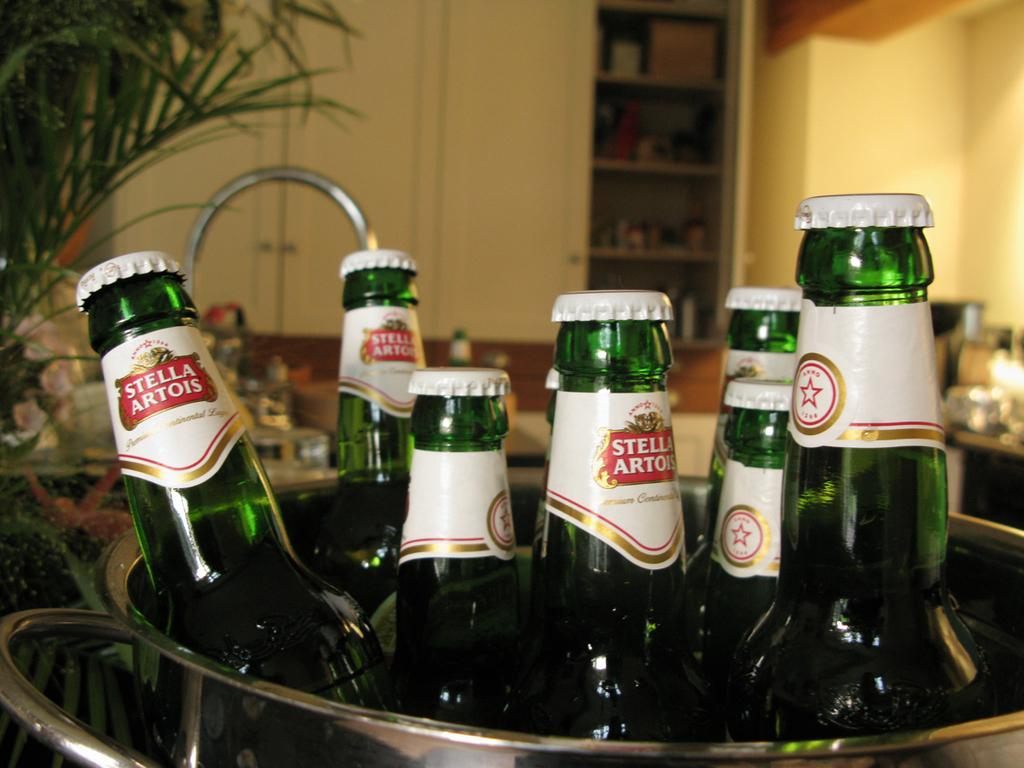<image>
Create a compact narrative representing the image presented. Bucket of Stella Artois beers with white caps. 